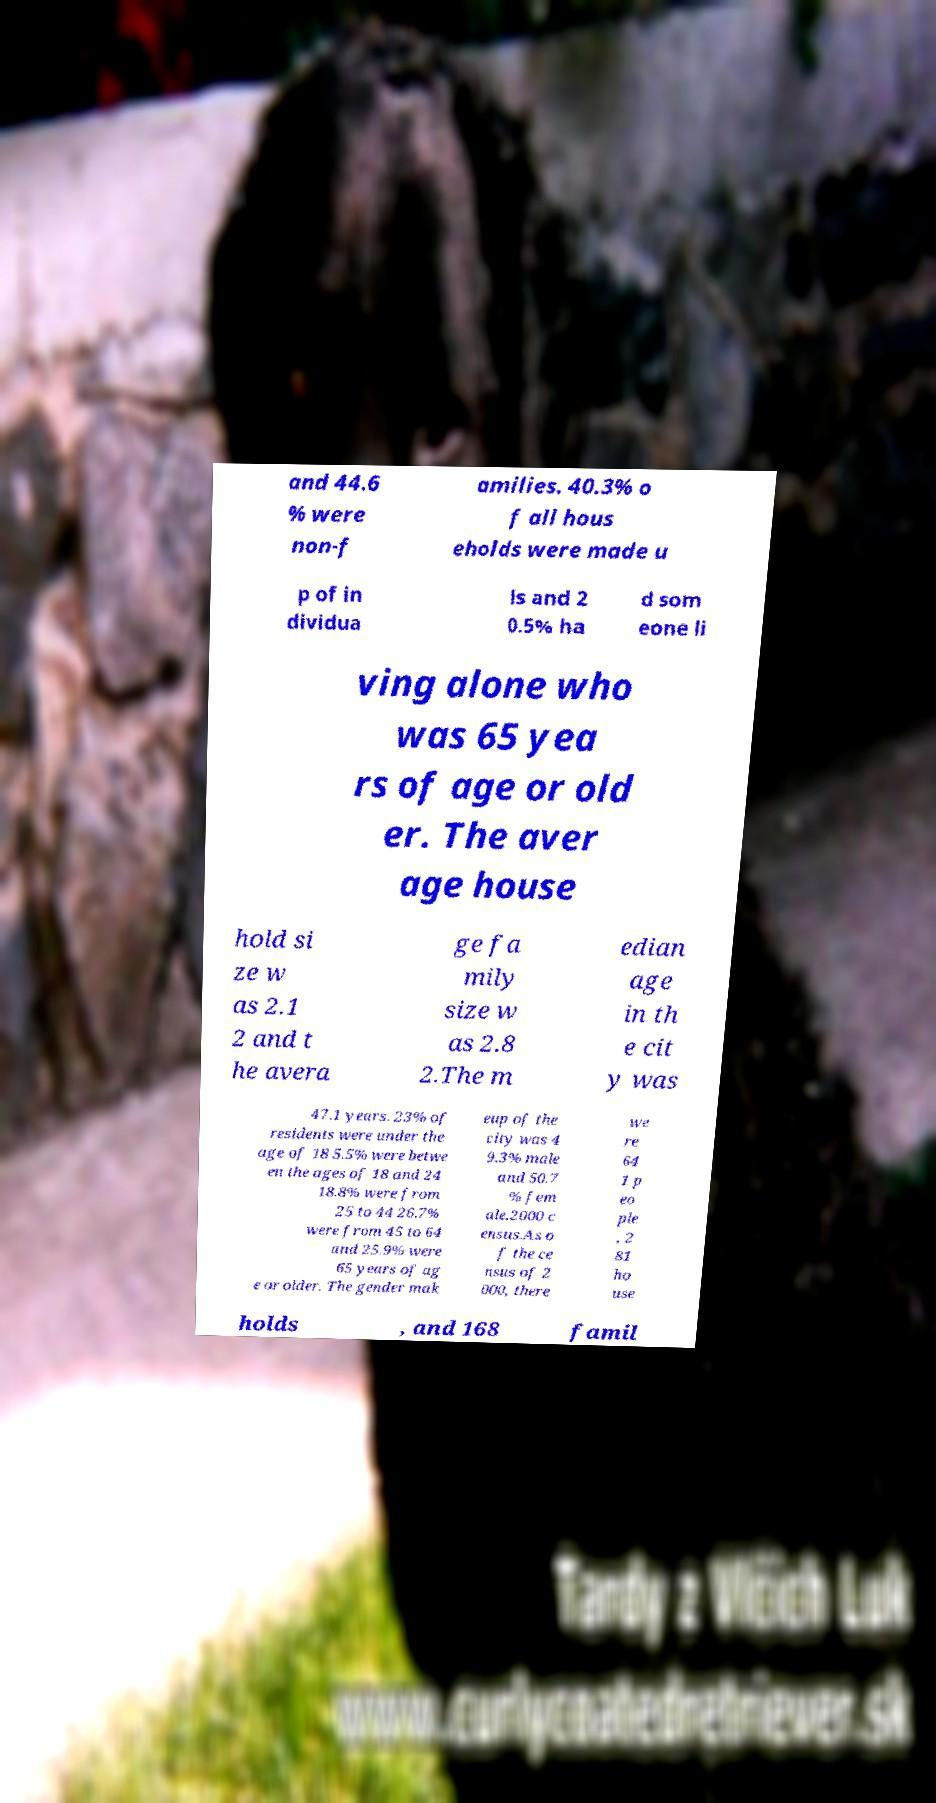Can you accurately transcribe the text from the provided image for me? and 44.6 % were non-f amilies. 40.3% o f all hous eholds were made u p of in dividua ls and 2 0.5% ha d som eone li ving alone who was 65 yea rs of age or old er. The aver age house hold si ze w as 2.1 2 and t he avera ge fa mily size w as 2.8 2.The m edian age in th e cit y was 47.1 years. 23% of residents were under the age of 18 5.5% were betwe en the ages of 18 and 24 18.8% were from 25 to 44 26.7% were from 45 to 64 and 25.9% were 65 years of ag e or older. The gender mak eup of the city was 4 9.3% male and 50.7 % fem ale.2000 c ensus.As o f the ce nsus of 2 000, there we re 64 1 p eo ple , 2 81 ho use holds , and 168 famil 